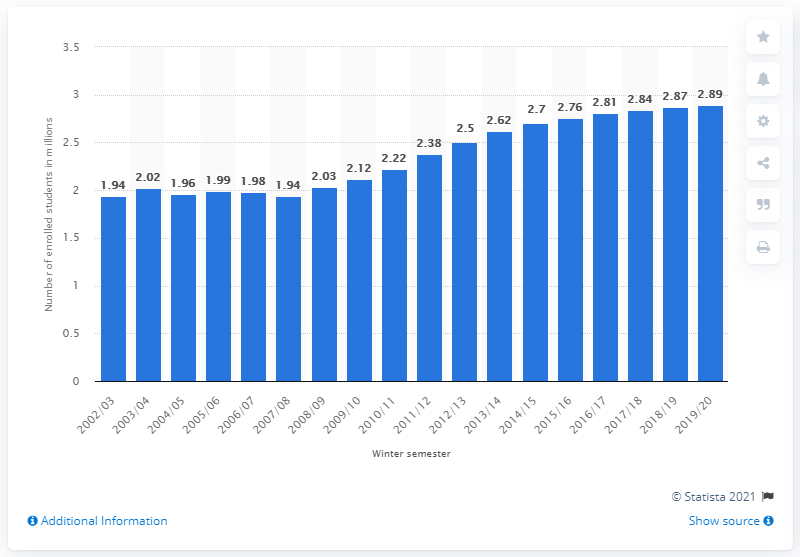Specify some key components in this picture. In the winter semester of 2019/2020, a total of 2,890 students were enrolled in German universities. 